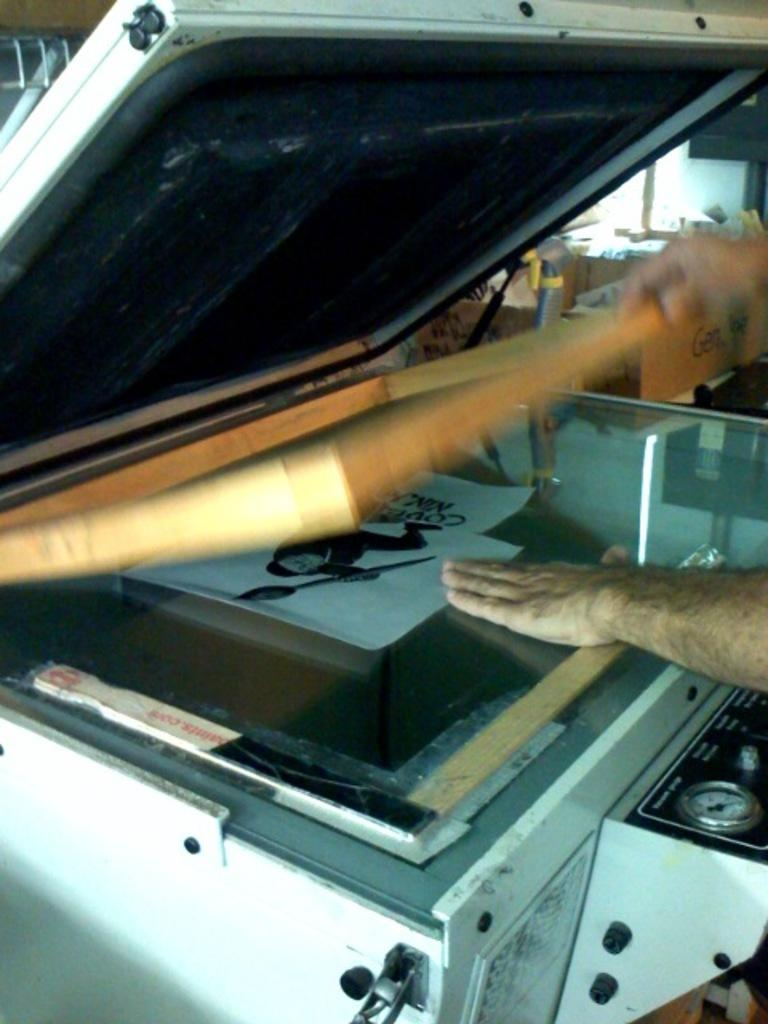What type of machine is present in the image? There is a xerox machine in the image. Can you describe the person in the image? There is a person in the image. What type of items are present with the person? There are papers with text in the image. What else can be seen in the image related to the person? There is a sketch of a person in the image. What other objects are present in the image that are not specified? There are other unspecified objects in the image. What type of joke is being told by the person in the image? There is no indication of a joke being told in the image; it only shows a person, a xerox machine, papers with text, and a sketch of a person. 